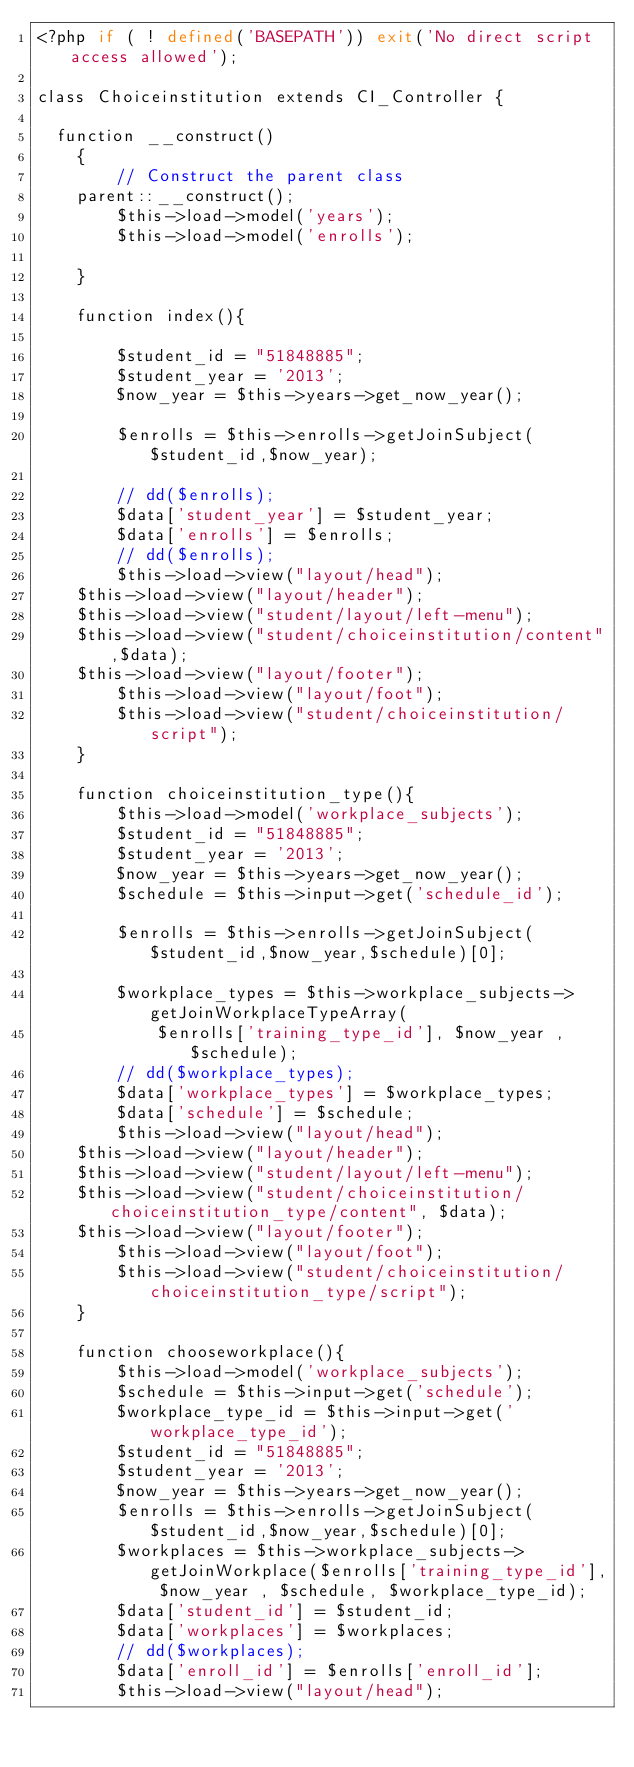<code> <loc_0><loc_0><loc_500><loc_500><_PHP_><?php if ( ! defined('BASEPATH')) exit('No direct script access allowed');

class Choiceinstitution extends CI_Controller {

	function __construct()
    {
        // Construct the parent class
		parent::__construct();
        $this->load->model('years');
        $this->load->model('enrolls');

    }

    function index(){

        $student_id = "51848885";
        $student_year = '2013';
        $now_year = $this->years->get_now_year();
        
        $enrolls = $this->enrolls->getJoinSubject($student_id,$now_year);

        // dd($enrolls);
        $data['student_year'] = $student_year;
        $data['enrolls'] = $enrolls;
        // dd($enrolls);
        $this->load->view("layout/head");
		$this->load->view("layout/header");
		$this->load->view("student/layout/left-menu");
		$this->load->view("student/choiceinstitution/content",$data);
		$this->load->view("layout/footer");
        $this->load->view("layout/foot");
        $this->load->view("student/choiceinstitution/script");
    }

    function choiceinstitution_type(){
        $this->load->model('workplace_subjects');
        $student_id = "51848885";
        $student_year = '2013';
        $now_year = $this->years->get_now_year();
        $schedule = $this->input->get('schedule_id');

        $enrolls = $this->enrolls->getJoinSubject($student_id,$now_year,$schedule)[0];
        
        $workplace_types = $this->workplace_subjects->getJoinWorkplaceTypeArray(
            $enrolls['training_type_id'], $now_year , $schedule);
        // dd($workplace_types);
        $data['workplace_types'] = $workplace_types;
        $data['schedule'] = $schedule;
        $this->load->view("layout/head");
		$this->load->view("layout/header");
		$this->load->view("student/layout/left-menu");
		$this->load->view("student/choiceinstitution/choiceinstitution_type/content", $data);
		$this->load->view("layout/footer");
        $this->load->view("layout/foot");
        $this->load->view("student/choiceinstitution/choiceinstitution_type/script");
    }

    function chooseworkplace(){
        $this->load->model('workplace_subjects');
        $schedule = $this->input->get('schedule');
        $workplace_type_id = $this->input->get('workplace_type_id');
        $student_id = "51848885";
        $student_year = '2013';
        $now_year = $this->years->get_now_year();
        $enrolls = $this->enrolls->getJoinSubject($student_id,$now_year,$schedule)[0];
        $workplaces = $this->workplace_subjects->getJoinWorkplace($enrolls['training_type_id'], $now_year , $schedule, $workplace_type_id);
        $data['student_id'] = $student_id;
        $data['workplaces'] = $workplaces;
        // dd($workplaces);
        $data['enroll_id'] = $enrolls['enroll_id'];
        $this->load->view("layout/head");</code> 